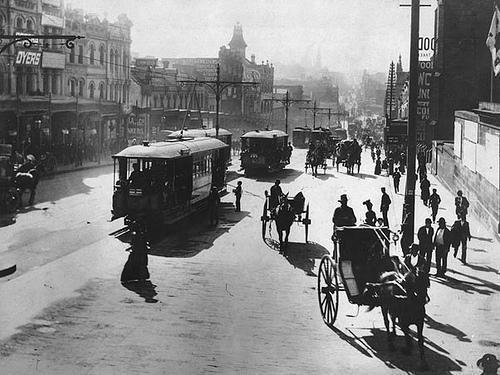How many people are visible?
Give a very brief answer. 1. 